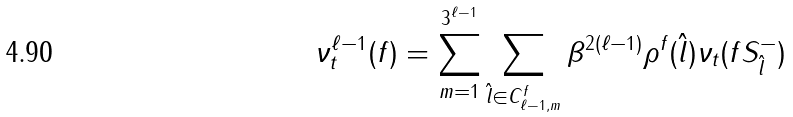Convert formula to latex. <formula><loc_0><loc_0><loc_500><loc_500>\nu _ { t } ^ { \ell - 1 } ( f ) = \sum _ { m = 1 } ^ { 3 ^ { \ell - 1 } } \sum _ { \hat { l } \in C ^ { f } _ { \ell - 1 , m } } \beta ^ { 2 ( \ell - 1 ) } \rho ^ { f } ( \hat { l } ) \nu _ { t } ( f S _ { \hat { l } } ^ { - } )</formula> 